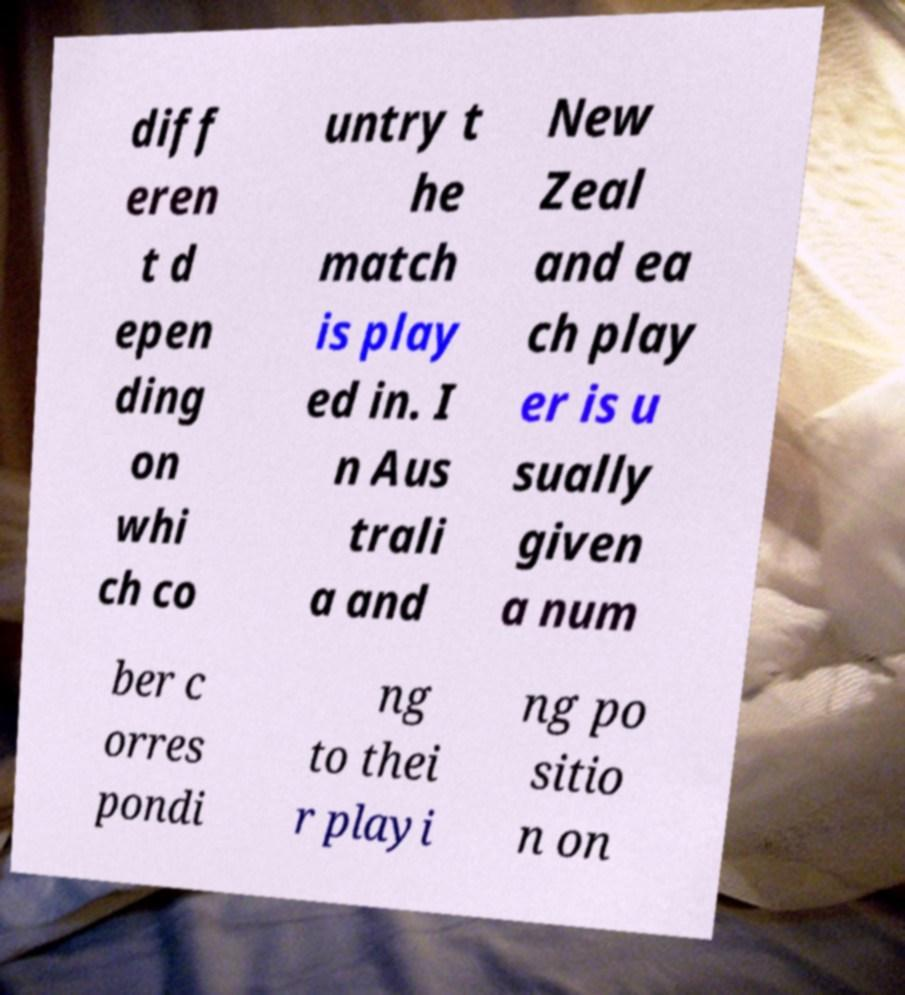Could you assist in decoding the text presented in this image and type it out clearly? diff eren t d epen ding on whi ch co untry t he match is play ed in. I n Aus trali a and New Zeal and ea ch play er is u sually given a num ber c orres pondi ng to thei r playi ng po sitio n on 